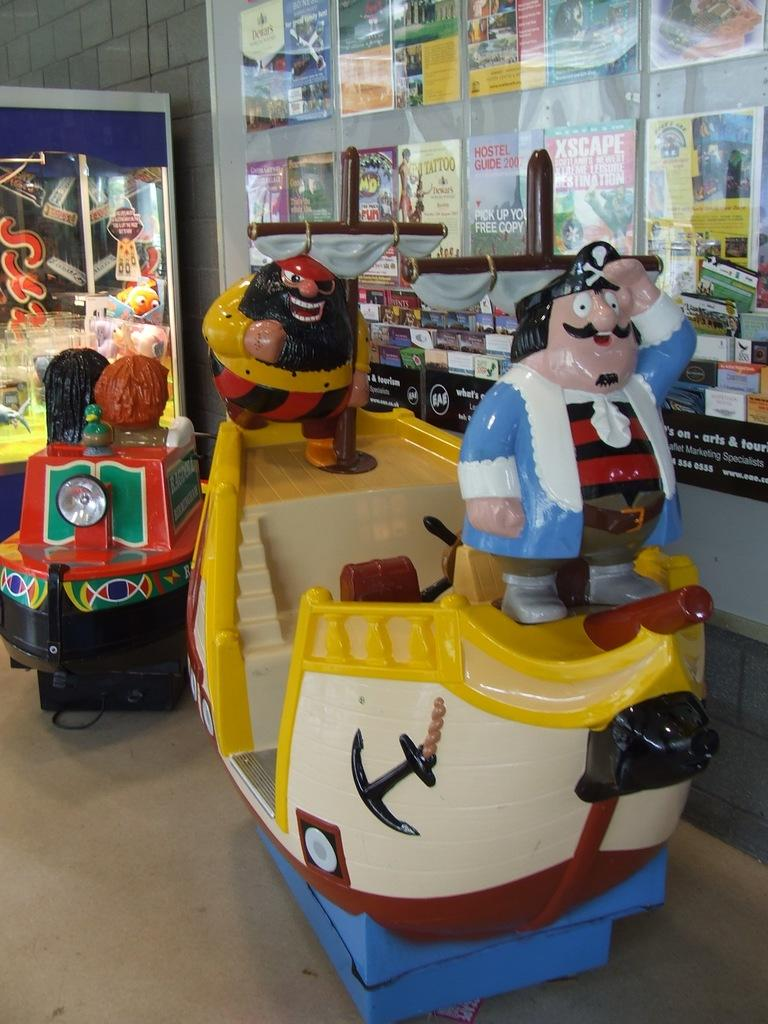Provide a one-sentence caption for the provided image. A sailor wearing a blue jacket stands in front of a 2007 Hostel Guide poster. 